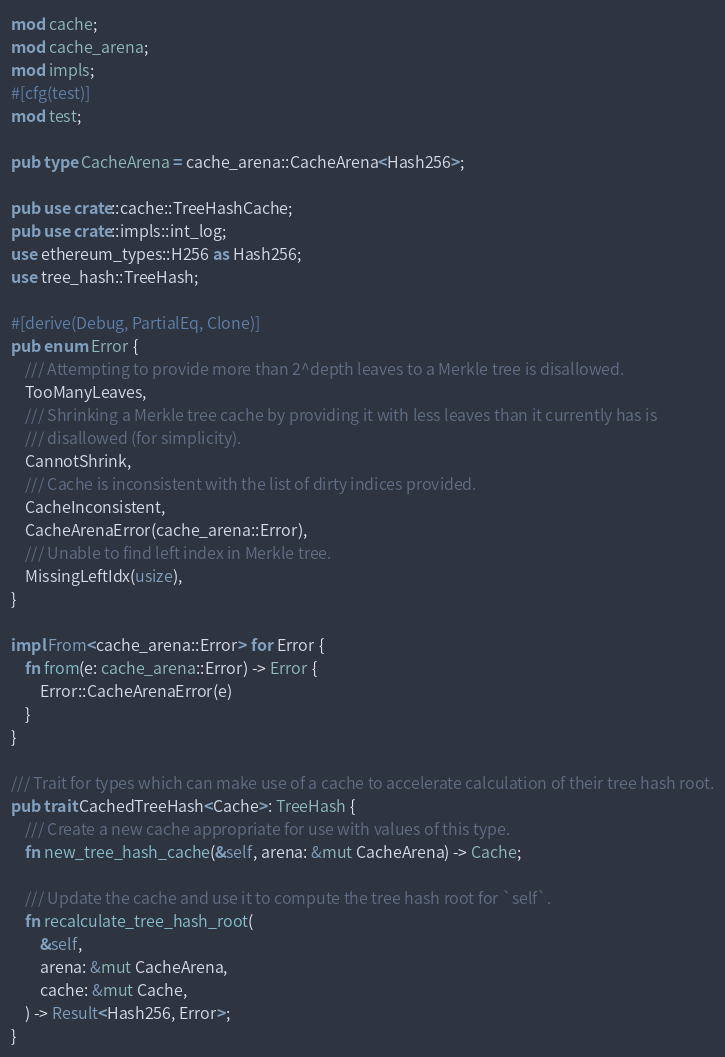Convert code to text. <code><loc_0><loc_0><loc_500><loc_500><_Rust_>mod cache;
mod cache_arena;
mod impls;
#[cfg(test)]
mod test;

pub type CacheArena = cache_arena::CacheArena<Hash256>;

pub use crate::cache::TreeHashCache;
pub use crate::impls::int_log;
use ethereum_types::H256 as Hash256;
use tree_hash::TreeHash;

#[derive(Debug, PartialEq, Clone)]
pub enum Error {
    /// Attempting to provide more than 2^depth leaves to a Merkle tree is disallowed.
    TooManyLeaves,
    /// Shrinking a Merkle tree cache by providing it with less leaves than it currently has is
    /// disallowed (for simplicity).
    CannotShrink,
    /// Cache is inconsistent with the list of dirty indices provided.
    CacheInconsistent,
    CacheArenaError(cache_arena::Error),
    /// Unable to find left index in Merkle tree.
    MissingLeftIdx(usize),
}

impl From<cache_arena::Error> for Error {
    fn from(e: cache_arena::Error) -> Error {
        Error::CacheArenaError(e)
    }
}

/// Trait for types which can make use of a cache to accelerate calculation of their tree hash root.
pub trait CachedTreeHash<Cache>: TreeHash {
    /// Create a new cache appropriate for use with values of this type.
    fn new_tree_hash_cache(&self, arena: &mut CacheArena) -> Cache;

    /// Update the cache and use it to compute the tree hash root for `self`.
    fn recalculate_tree_hash_root(
        &self,
        arena: &mut CacheArena,
        cache: &mut Cache,
    ) -> Result<Hash256, Error>;
}
</code> 